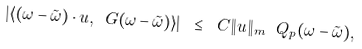<formula> <loc_0><loc_0><loc_500><loc_500>| \langle ( \omega - \tilde { \omega } ) \cdot u , \ G ( \omega - \tilde { \omega } ) \rangle | \ \leq \ C \| u \| _ { m } \ Q _ { p } ( \omega - \tilde { \omega } ) ,</formula> 